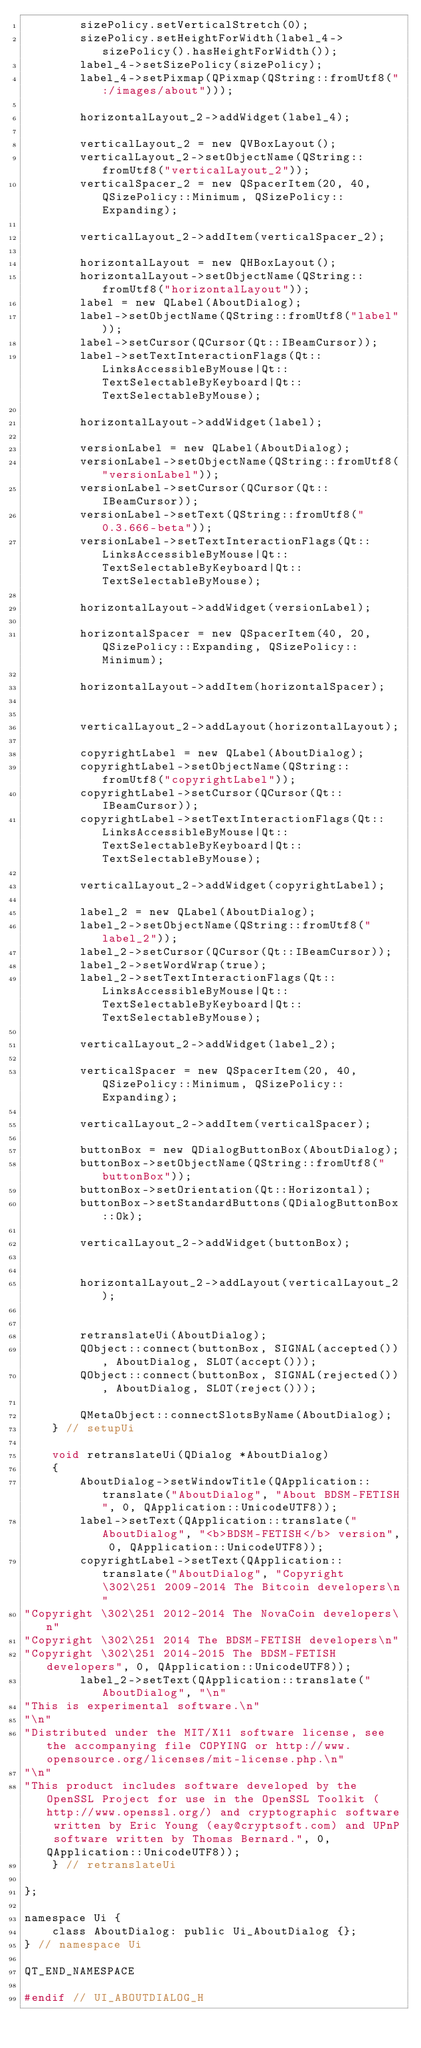Convert code to text. <code><loc_0><loc_0><loc_500><loc_500><_C_>        sizePolicy.setVerticalStretch(0);
        sizePolicy.setHeightForWidth(label_4->sizePolicy().hasHeightForWidth());
        label_4->setSizePolicy(sizePolicy);
        label_4->setPixmap(QPixmap(QString::fromUtf8(":/images/about")));

        horizontalLayout_2->addWidget(label_4);

        verticalLayout_2 = new QVBoxLayout();
        verticalLayout_2->setObjectName(QString::fromUtf8("verticalLayout_2"));
        verticalSpacer_2 = new QSpacerItem(20, 40, QSizePolicy::Minimum, QSizePolicy::Expanding);

        verticalLayout_2->addItem(verticalSpacer_2);

        horizontalLayout = new QHBoxLayout();
        horizontalLayout->setObjectName(QString::fromUtf8("horizontalLayout"));
        label = new QLabel(AboutDialog);
        label->setObjectName(QString::fromUtf8("label"));
        label->setCursor(QCursor(Qt::IBeamCursor));
        label->setTextInteractionFlags(Qt::LinksAccessibleByMouse|Qt::TextSelectableByKeyboard|Qt::TextSelectableByMouse);

        horizontalLayout->addWidget(label);

        versionLabel = new QLabel(AboutDialog);
        versionLabel->setObjectName(QString::fromUtf8("versionLabel"));
        versionLabel->setCursor(QCursor(Qt::IBeamCursor));
        versionLabel->setText(QString::fromUtf8("0.3.666-beta"));
        versionLabel->setTextInteractionFlags(Qt::LinksAccessibleByMouse|Qt::TextSelectableByKeyboard|Qt::TextSelectableByMouse);

        horizontalLayout->addWidget(versionLabel);

        horizontalSpacer = new QSpacerItem(40, 20, QSizePolicy::Expanding, QSizePolicy::Minimum);

        horizontalLayout->addItem(horizontalSpacer);


        verticalLayout_2->addLayout(horizontalLayout);

        copyrightLabel = new QLabel(AboutDialog);
        copyrightLabel->setObjectName(QString::fromUtf8("copyrightLabel"));
        copyrightLabel->setCursor(QCursor(Qt::IBeamCursor));
        copyrightLabel->setTextInteractionFlags(Qt::LinksAccessibleByMouse|Qt::TextSelectableByKeyboard|Qt::TextSelectableByMouse);

        verticalLayout_2->addWidget(copyrightLabel);

        label_2 = new QLabel(AboutDialog);
        label_2->setObjectName(QString::fromUtf8("label_2"));
        label_2->setCursor(QCursor(Qt::IBeamCursor));
        label_2->setWordWrap(true);
        label_2->setTextInteractionFlags(Qt::LinksAccessibleByMouse|Qt::TextSelectableByKeyboard|Qt::TextSelectableByMouse);

        verticalLayout_2->addWidget(label_2);

        verticalSpacer = new QSpacerItem(20, 40, QSizePolicy::Minimum, QSizePolicy::Expanding);

        verticalLayout_2->addItem(verticalSpacer);

        buttonBox = new QDialogButtonBox(AboutDialog);
        buttonBox->setObjectName(QString::fromUtf8("buttonBox"));
        buttonBox->setOrientation(Qt::Horizontal);
        buttonBox->setStandardButtons(QDialogButtonBox::Ok);

        verticalLayout_2->addWidget(buttonBox);


        horizontalLayout_2->addLayout(verticalLayout_2);


        retranslateUi(AboutDialog);
        QObject::connect(buttonBox, SIGNAL(accepted()), AboutDialog, SLOT(accept()));
        QObject::connect(buttonBox, SIGNAL(rejected()), AboutDialog, SLOT(reject()));

        QMetaObject::connectSlotsByName(AboutDialog);
    } // setupUi

    void retranslateUi(QDialog *AboutDialog)
    {
        AboutDialog->setWindowTitle(QApplication::translate("AboutDialog", "About BDSM-FETISH", 0, QApplication::UnicodeUTF8));
        label->setText(QApplication::translate("AboutDialog", "<b>BDSM-FETISH</b> version", 0, QApplication::UnicodeUTF8));
        copyrightLabel->setText(QApplication::translate("AboutDialog", "Copyright \302\251 2009-2014 The Bitcoin developers\n"
"Copyright \302\251 2012-2014 The NovaCoin developers\n"
"Copyright \302\251 2014 The BDSM-FETISH developers\n"
"Copyright \302\251 2014-2015 The BDSM-FETISH developers", 0, QApplication::UnicodeUTF8));
        label_2->setText(QApplication::translate("AboutDialog", "\n"
"This is experimental software.\n"
"\n"
"Distributed under the MIT/X11 software license, see the accompanying file COPYING or http://www.opensource.org/licenses/mit-license.php.\n"
"\n"
"This product includes software developed by the OpenSSL Project for use in the OpenSSL Toolkit (http://www.openssl.org/) and cryptographic software written by Eric Young (eay@cryptsoft.com) and UPnP software written by Thomas Bernard.", 0, QApplication::UnicodeUTF8));
    } // retranslateUi

};

namespace Ui {
    class AboutDialog: public Ui_AboutDialog {};
} // namespace Ui

QT_END_NAMESPACE

#endif // UI_ABOUTDIALOG_H
</code> 